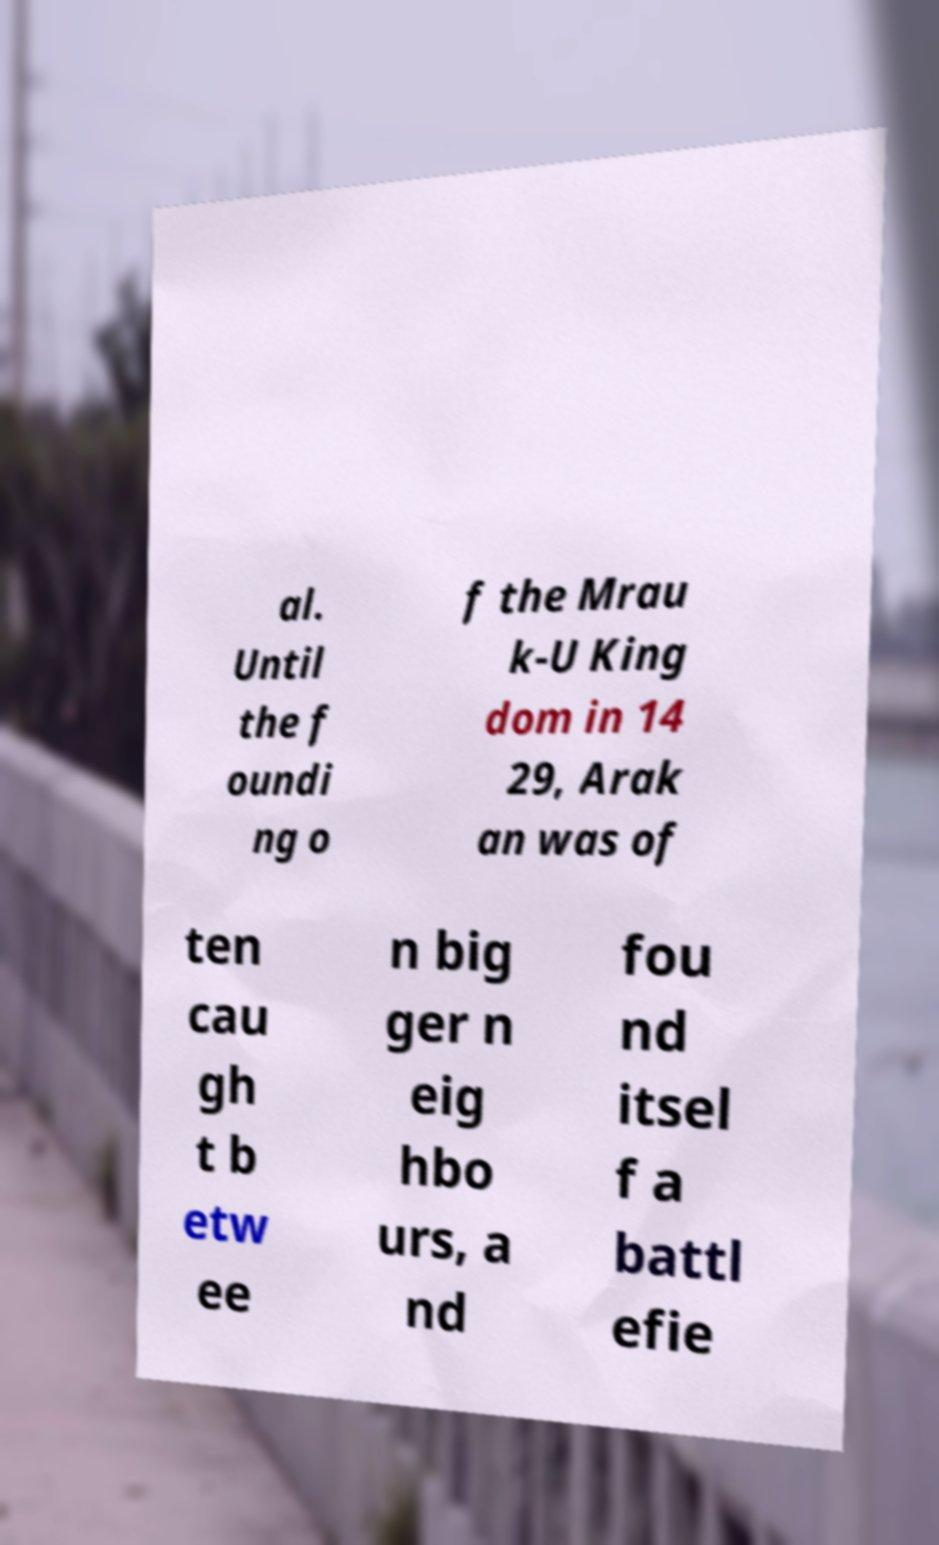What messages or text are displayed in this image? I need them in a readable, typed format. al. Until the f oundi ng o f the Mrau k-U King dom in 14 29, Arak an was of ten cau gh t b etw ee n big ger n eig hbo urs, a nd fou nd itsel f a battl efie 